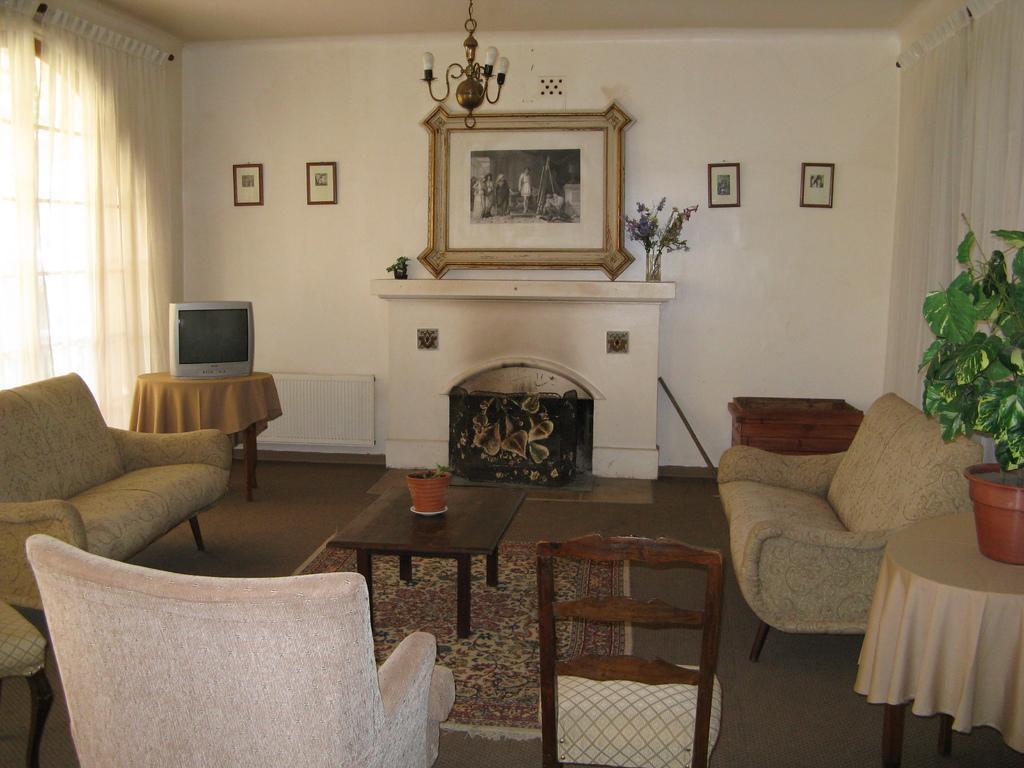In one or two sentences, can you explain what this image depicts? The picture is taken inside a room where in the centre there is a fire place and at the right corner there is a sofa and table with cloth and one plant on it and at the left corner on sofa beside that one table an done tv on it and there is a big white wall where photos are placed on it and left corner one big curtain and at the right corner another white big curtain is present and in the middle there is one table on that on pot is present, under the table there is one carpet and one chair,sofa is present. 